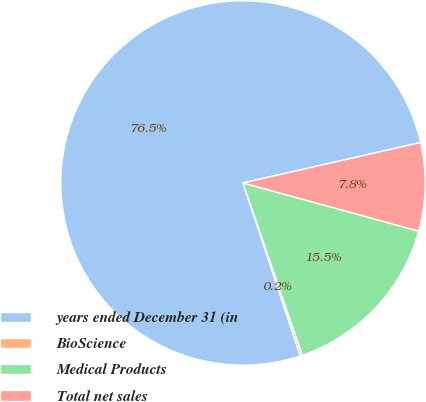Convert chart to OTSL. <chart><loc_0><loc_0><loc_500><loc_500><pie_chart><fcel>years ended December 31 (in<fcel>BioScience<fcel>Medical Products<fcel>Total net sales<nl><fcel>76.53%<fcel>0.19%<fcel>15.46%<fcel>7.82%<nl></chart> 